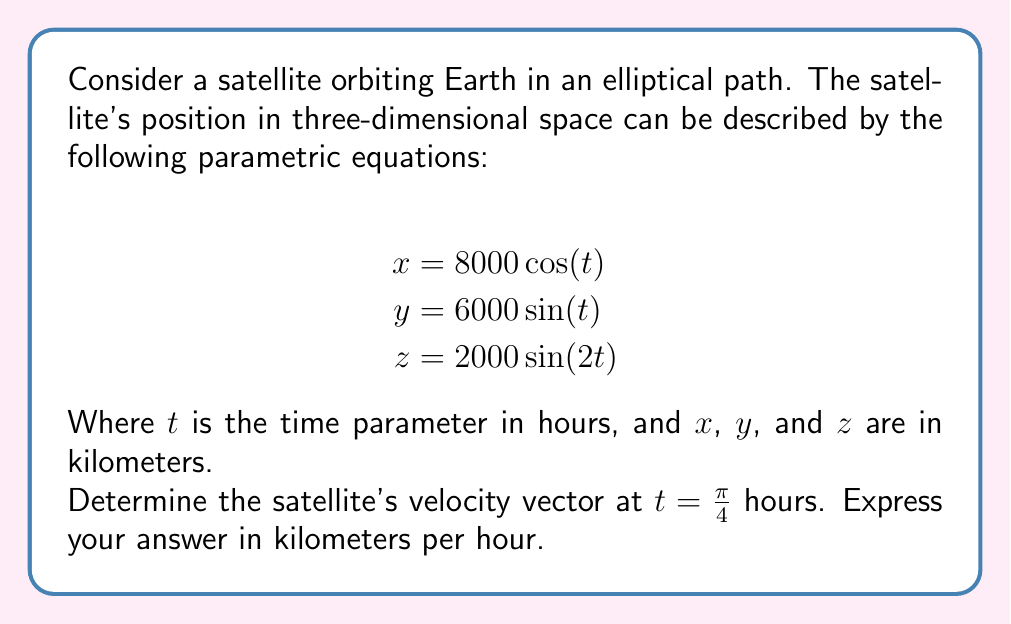Can you answer this question? To solve this problem, we need to follow these steps:

1) The velocity vector is given by the first derivative of the position vector with respect to time. So, we need to differentiate each component with respect to $t$.

2) For $x(t) = 8000 \cos(t)$:
   $$\frac{dx}{dt} = -8000 \sin(t)$$

3) For $y(t) = 6000 \sin(t)$:
   $$\frac{dy}{dt} = 6000 \cos(t)$$

4) For $z(t) = 2000 \sin(2t)$:
   $$\frac{dz}{dt} = 4000 \cos(2t)$$

5) Now, we have the velocity vector as a function of $t$:
   $$\vec{v}(t) = \left\langle -8000 \sin(t), 6000 \cos(t), 4000 \cos(2t) \right\rangle$$

6) We need to evaluate this at $t = \frac{\pi}{4}$. Let's calculate each component:

   For $x$: $-8000 \sin(\frac{\pi}{4}) = -8000 \cdot \frac{\sqrt{2}}{2} = -4000\sqrt{2}$
   
   For $y$: $6000 \cos(\frac{\pi}{4}) = 6000 \cdot \frac{\sqrt{2}}{2} = 3000\sqrt{2}$
   
   For $z$: $4000 \cos(2\cdot\frac{\pi}{4}) = 4000 \cos(\frac{\pi}{2}) = 0$

7) Therefore, the velocity vector at $t = \frac{\pi}{4}$ is:
   $$\vec{v}(\frac{\pi}{4}) = \left\langle -4000\sqrt{2}, 3000\sqrt{2}, 0 \right\rangle$$

This vector is in kilometers per hour.
Answer: The satellite's velocity vector at $t = \frac{\pi}{4}$ hours is:
$$\vec{v}(\frac{\pi}{4}) = \left\langle -4000\sqrt{2}, 3000\sqrt{2}, 0 \right\rangle$$ km/h 